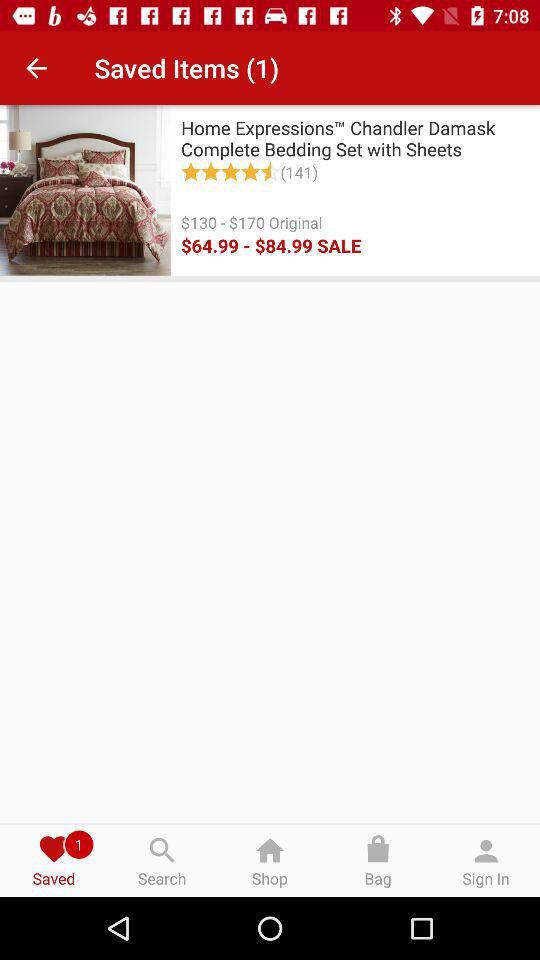How much is the original price of the product?
Answer the question using a single word or phrase. $130 - $170 